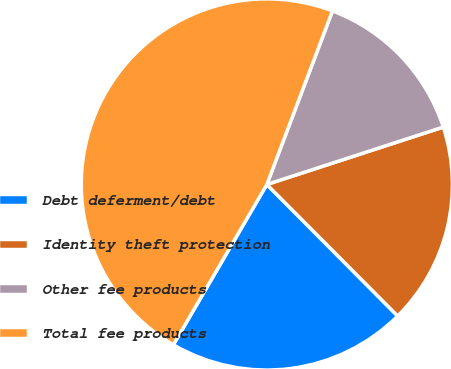Convert chart. <chart><loc_0><loc_0><loc_500><loc_500><pie_chart><fcel>Debt deferment/debt<fcel>Identity theft protection<fcel>Other fee products<fcel>Total fee products<nl><fcel>20.86%<fcel>17.55%<fcel>14.24%<fcel>47.35%<nl></chart> 